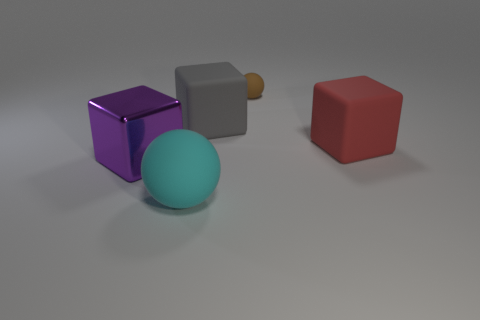Subtract all purple shiny cubes. How many cubes are left? 2 Add 4 brown balls. How many objects exist? 9 Subtract all blocks. How many objects are left? 2 Subtract all large cyan things. Subtract all tiny matte things. How many objects are left? 3 Add 2 purple shiny objects. How many purple shiny objects are left? 3 Add 5 purple shiny objects. How many purple shiny objects exist? 6 Subtract 0 brown blocks. How many objects are left? 5 Subtract all cyan blocks. Subtract all red cylinders. How many blocks are left? 3 